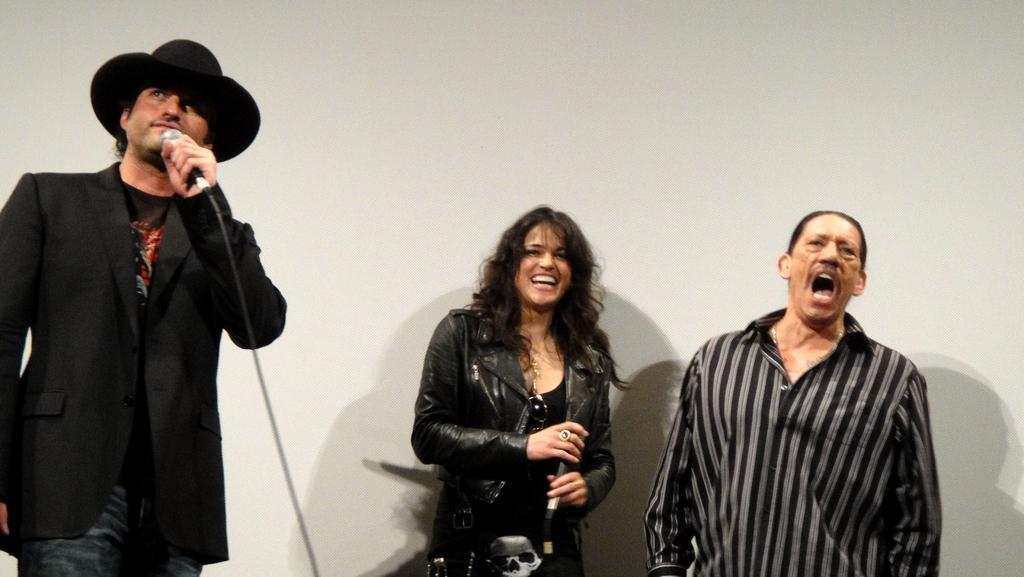Describe this image in one or two sentences. In this picture we can see three people two men and one woman and the man on the left side is holding a microphone in the background we can see a wall the man on the right side is shouting something. 